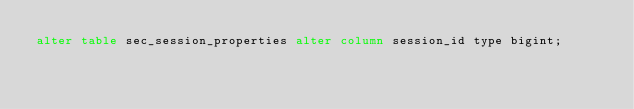Convert code to text. <code><loc_0><loc_0><loc_500><loc_500><_SQL_>alter table sec_session_properties alter column session_id type bigint;
</code> 